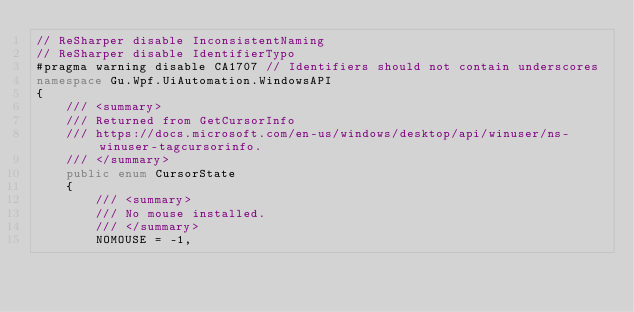Convert code to text. <code><loc_0><loc_0><loc_500><loc_500><_C#_>// ReSharper disable InconsistentNaming
// ReSharper disable IdentifierTypo
#pragma warning disable CA1707 // Identifiers should not contain underscores
namespace Gu.Wpf.UiAutomation.WindowsAPI
{
    /// <summary>
    /// Returned from GetCursorInfo
    /// https://docs.microsoft.com/en-us/windows/desktop/api/winuser/ns-winuser-tagcursorinfo.
    /// </summary>
    public enum CursorState
    {
        /// <summary>
        /// No mouse installed.
        /// </summary>
        NOMOUSE = -1,
</code> 